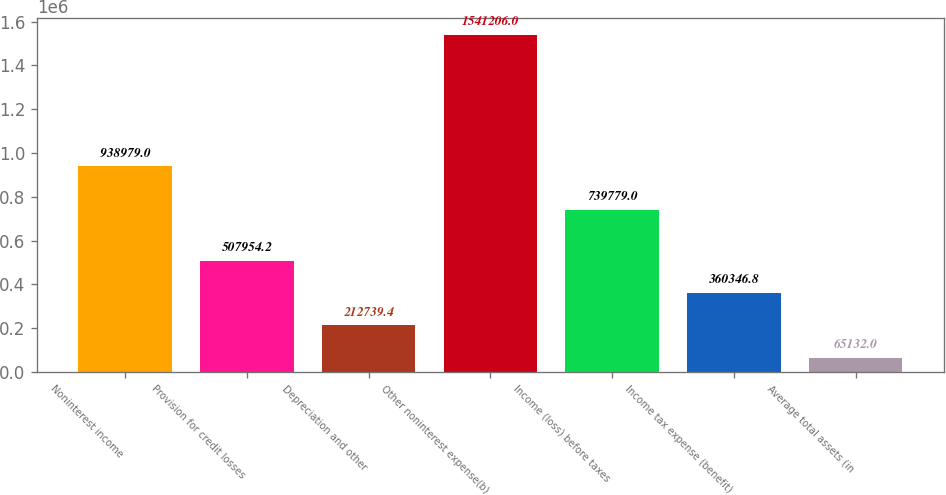<chart> <loc_0><loc_0><loc_500><loc_500><bar_chart><fcel>Noninterest income<fcel>Provision for credit losses<fcel>Depreciation and other<fcel>Other noninterest expense(b)<fcel>Income (loss) before taxes<fcel>Income tax expense (benefit)<fcel>Average total assets (in<nl><fcel>938979<fcel>507954<fcel>212739<fcel>1.54121e+06<fcel>739779<fcel>360347<fcel>65132<nl></chart> 